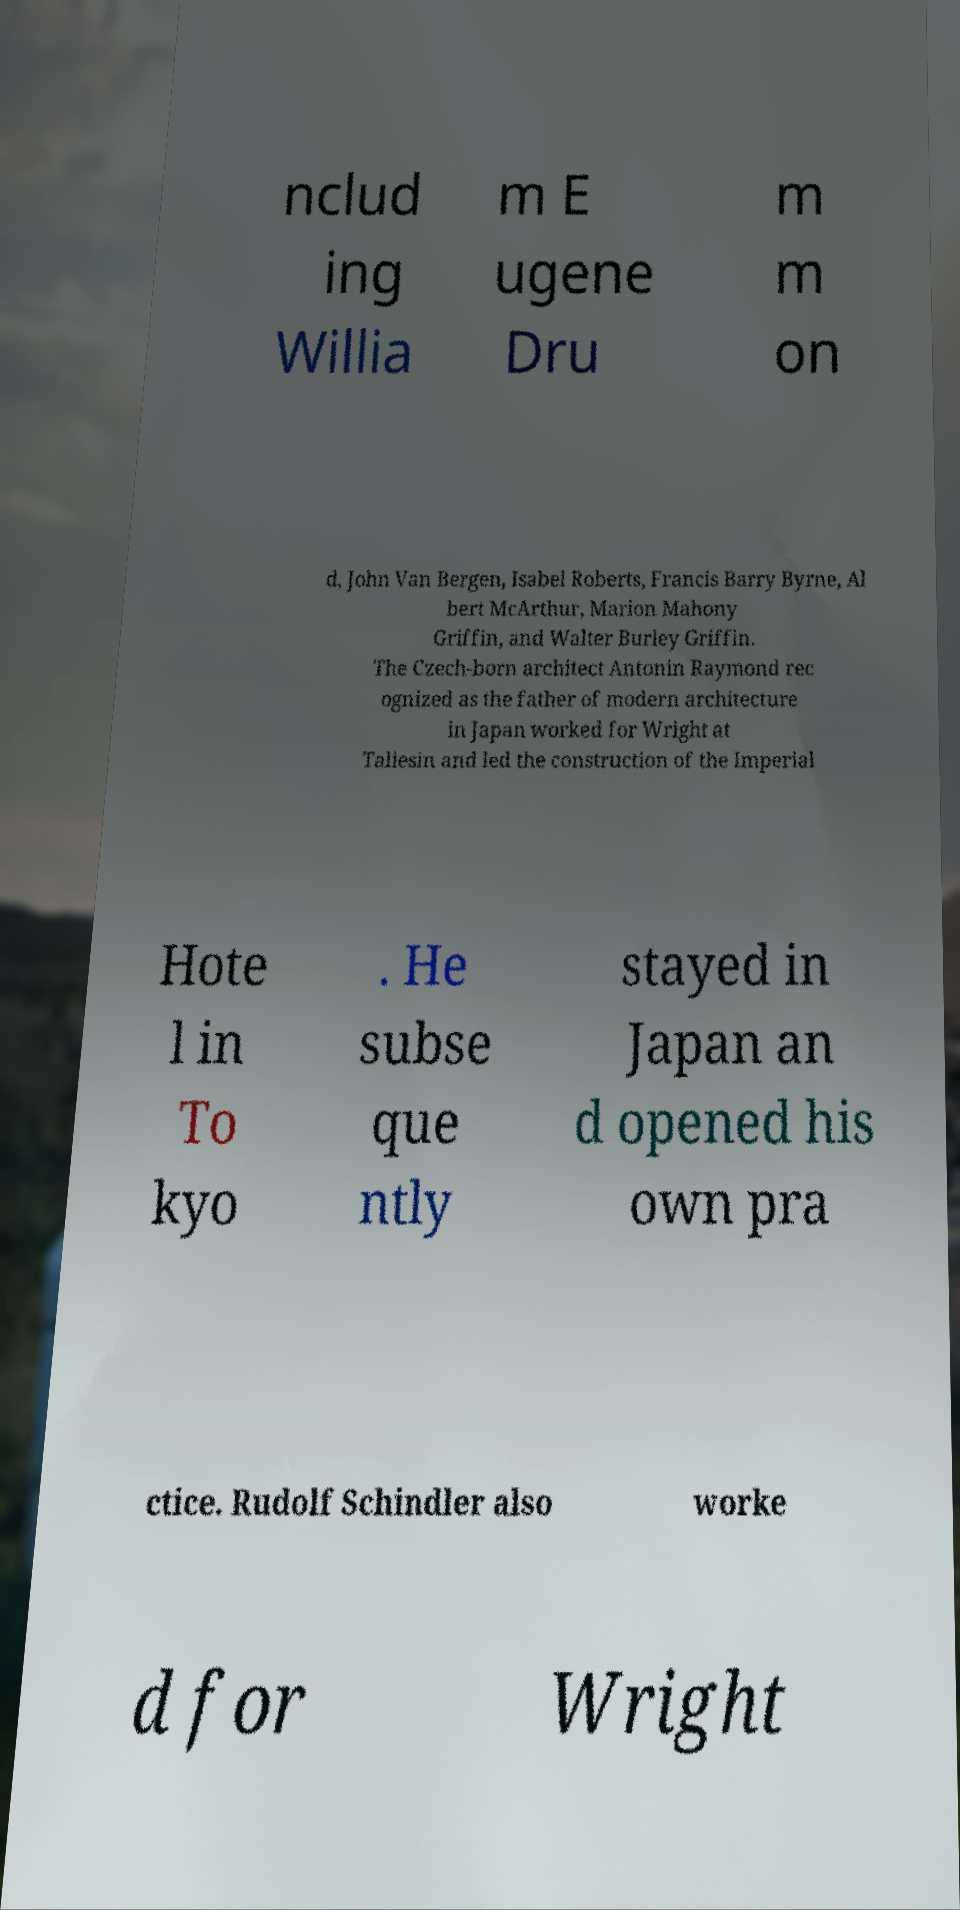Please identify and transcribe the text found in this image. nclud ing Willia m E ugene Dru m m on d, John Van Bergen, Isabel Roberts, Francis Barry Byrne, Al bert McArthur, Marion Mahony Griffin, and Walter Burley Griffin. The Czech-born architect Antonin Raymond rec ognized as the father of modern architecture in Japan worked for Wright at Taliesin and led the construction of the Imperial Hote l in To kyo . He subse que ntly stayed in Japan an d opened his own pra ctice. Rudolf Schindler also worke d for Wright 